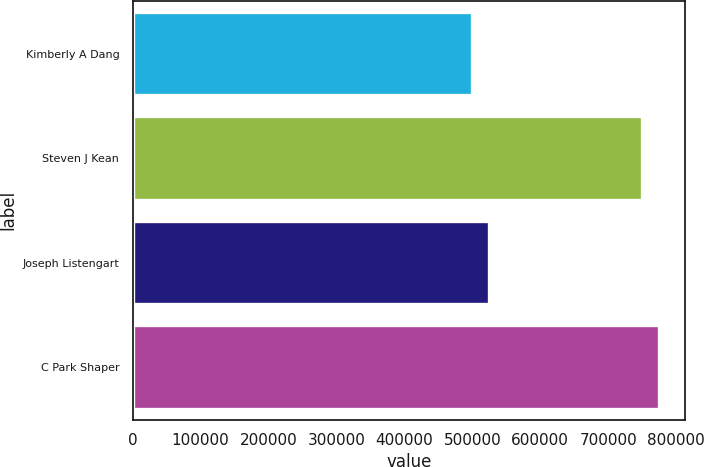Convert chart to OTSL. <chart><loc_0><loc_0><loc_500><loc_500><bar_chart><fcel>Kimberly A Dang<fcel>Steven J Kean<fcel>Joseph Listengart<fcel>C Park Shaper<nl><fcel>500000<fcel>750000<fcel>525000<fcel>775000<nl></chart> 